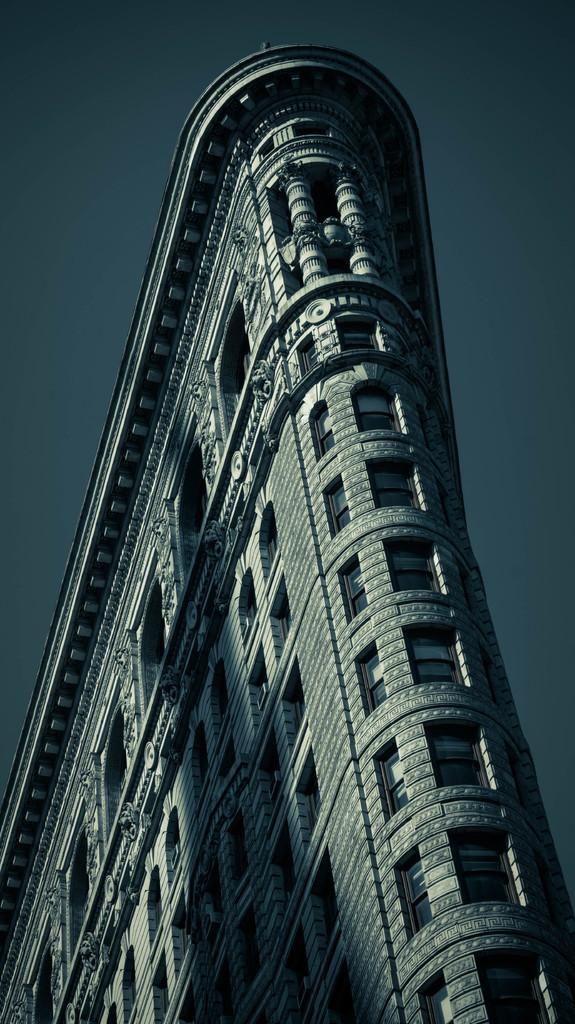Could you give a brief overview of what you see in this image? In this image there is a tall building. There are small windows on the building. There is a sky. 